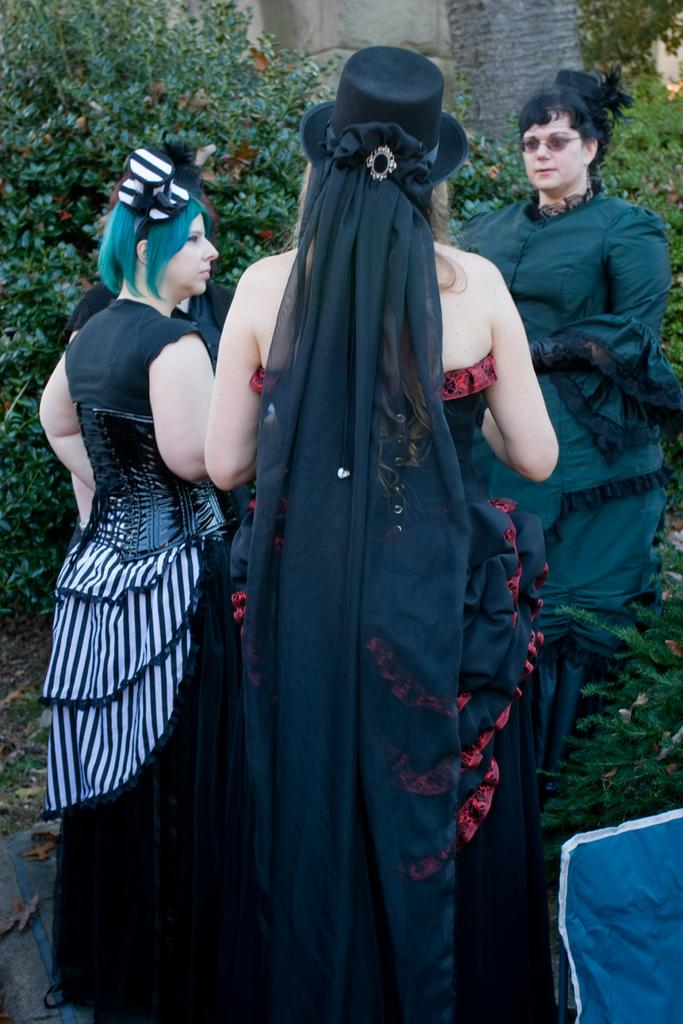How many people are in the image? There are three people standing in the image. What are the people wearing? The people are wearing costumes. What can be seen in the background of the image? There are trees in the background of the image. What is the color and location of the object at the right bottom of the image? The object is blue and located at the right bottom of the image. Can you tell me how many fairies are playing chess in the image? There are no fairies or chess games present in the image. 